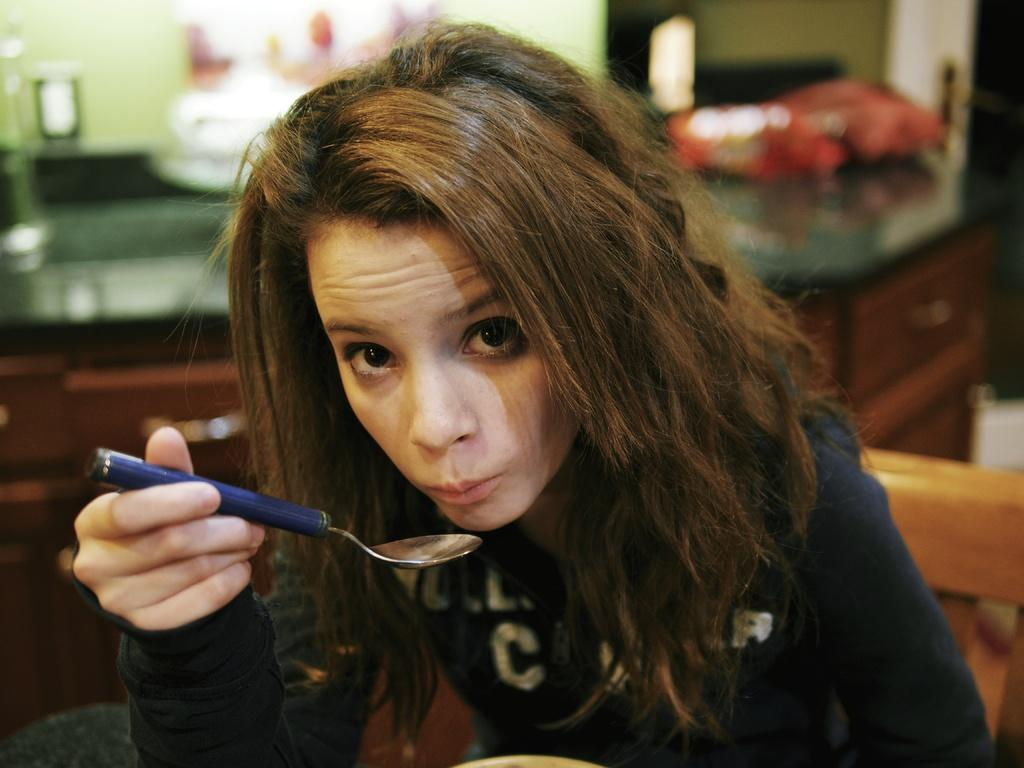Who is the main subject in the image? There is a girl in the image. What is the girl doing in the image? The girl is sitting on a chair. What is the girl holding in the image? The girl is holding a spoon. What can be seen in the background of the image? There is a wall, lights, and a table in the background of the image. What type of shirt is the girl wearing in the image? The provided facts do not mention the girl's shirt, so we cannot determine the type of shirt she is wearing. Can you tell me if the girl has a locket in the image? There is no mention of a locket in the provided facts, so we cannot determine if the girl has a locket in the image. 